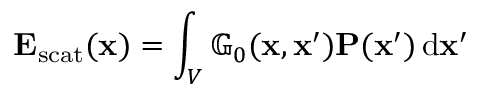Convert formula to latex. <formula><loc_0><loc_0><loc_500><loc_500>E _ { s c a t } ( x ) = \int _ { V } \mathbb { G } _ { 0 } ( x , x ^ { \prime } ) P ( x ^ { \prime } ) \, d x ^ { \prime }</formula> 